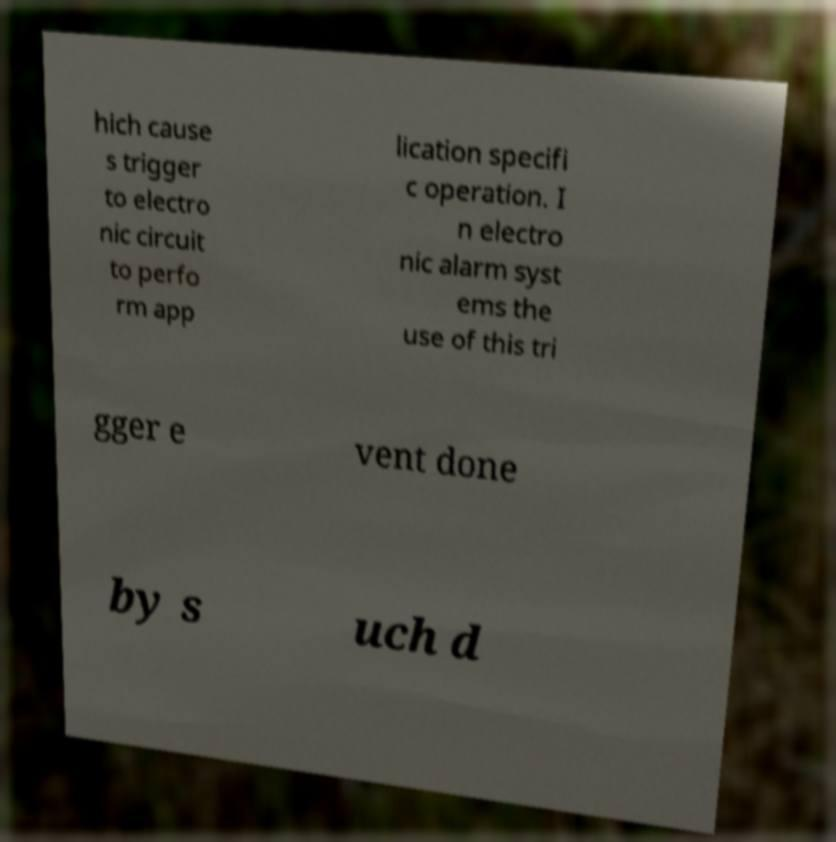Can you accurately transcribe the text from the provided image for me? hich cause s trigger to electro nic circuit to perfo rm app lication specifi c operation. I n electro nic alarm syst ems the use of this tri gger e vent done by s uch d 